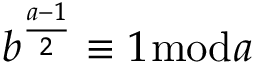<formula> <loc_0><loc_0><loc_500><loc_500>b ^ { \frac { a - 1 } { 2 } } \equiv 1 { \bmod { a } }</formula> 